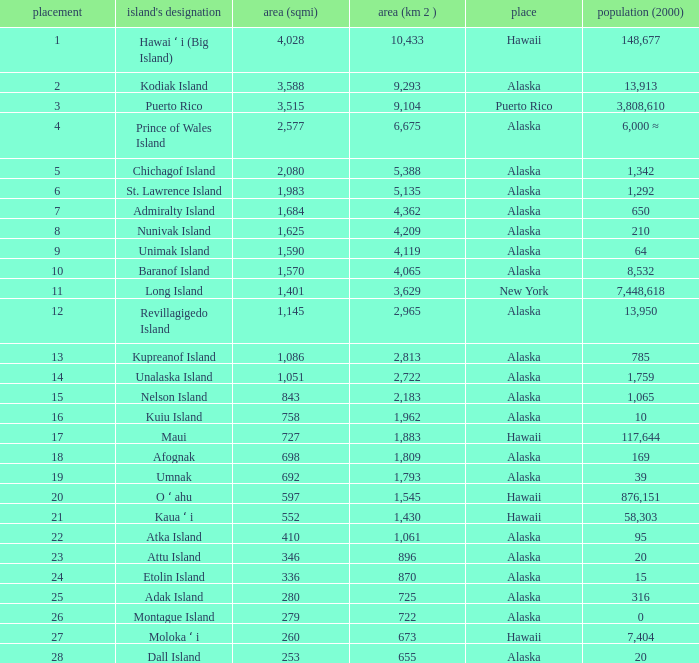What is the largest area in Alaska with a population of 39 and rank over 19? None. 